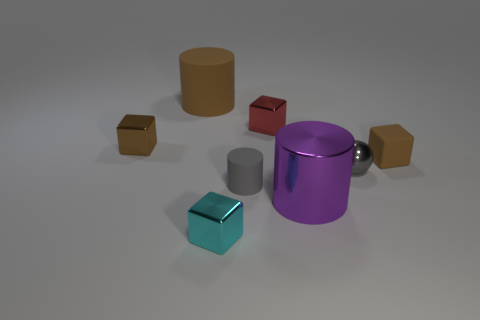Subtract all brown cylinders. How many cylinders are left? 2 Subtract all gray blocks. Subtract all brown balls. How many blocks are left? 4 Add 1 big purple metal things. How many objects exist? 9 Subtract all spheres. How many objects are left? 7 Add 2 small rubber objects. How many small rubber objects exist? 4 Subtract 0 green spheres. How many objects are left? 8 Subtract all brown blocks. Subtract all tiny brown metallic spheres. How many objects are left? 6 Add 3 tiny cylinders. How many tiny cylinders are left? 4 